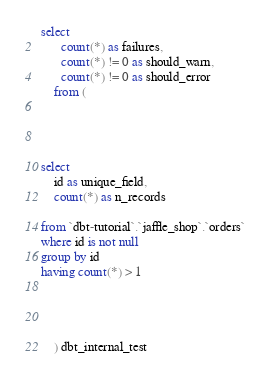Convert code to text. <code><loc_0><loc_0><loc_500><loc_500><_SQL_>select
      count(*) as failures,
      count(*) != 0 as should_warn,
      count(*) != 0 as should_error
    from (
      
    
    

select
    id as unique_field,
    count(*) as n_records

from `dbt-tutorial`.`jaffle_shop`.`orders`
where id is not null
group by id
having count(*) > 1



      
    ) dbt_internal_test</code> 